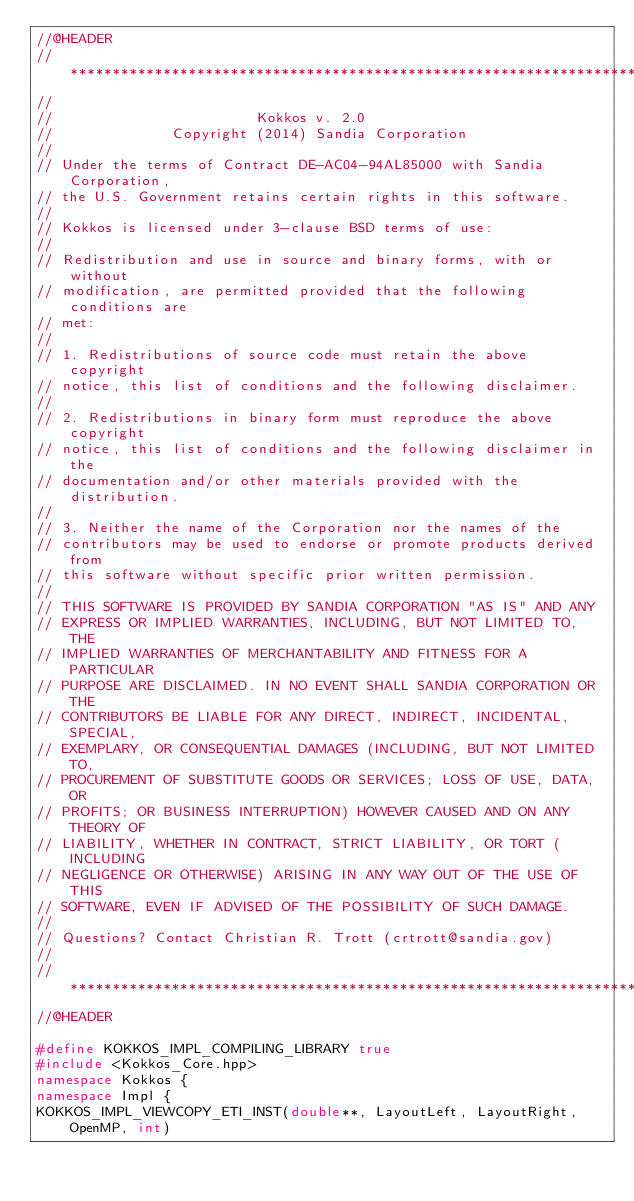Convert code to text. <code><loc_0><loc_0><loc_500><loc_500><_C++_>//@HEADER
// ************************************************************************
//
//                        Kokkos v. 2.0
//              Copyright (2014) Sandia Corporation
//
// Under the terms of Contract DE-AC04-94AL85000 with Sandia Corporation,
// the U.S. Government retains certain rights in this software.
//
// Kokkos is licensed under 3-clause BSD terms of use:
//
// Redistribution and use in source and binary forms, with or without
// modification, are permitted provided that the following conditions are
// met:
//
// 1. Redistributions of source code must retain the above copyright
// notice, this list of conditions and the following disclaimer.
//
// 2. Redistributions in binary form must reproduce the above copyright
// notice, this list of conditions and the following disclaimer in the
// documentation and/or other materials provided with the distribution.
//
// 3. Neither the name of the Corporation nor the names of the
// contributors may be used to endorse or promote products derived from
// this software without specific prior written permission.
//
// THIS SOFTWARE IS PROVIDED BY SANDIA CORPORATION "AS IS" AND ANY
// EXPRESS OR IMPLIED WARRANTIES, INCLUDING, BUT NOT LIMITED TO, THE
// IMPLIED WARRANTIES OF MERCHANTABILITY AND FITNESS FOR A PARTICULAR
// PURPOSE ARE DISCLAIMED. IN NO EVENT SHALL SANDIA CORPORATION OR THE
// CONTRIBUTORS BE LIABLE FOR ANY DIRECT, INDIRECT, INCIDENTAL, SPECIAL,
// EXEMPLARY, OR CONSEQUENTIAL DAMAGES (INCLUDING, BUT NOT LIMITED TO,
// PROCUREMENT OF SUBSTITUTE GOODS OR SERVICES; LOSS OF USE, DATA, OR
// PROFITS; OR BUSINESS INTERRUPTION) HOWEVER CAUSED AND ON ANY THEORY OF
// LIABILITY, WHETHER IN CONTRACT, STRICT LIABILITY, OR TORT (INCLUDING
// NEGLIGENCE OR OTHERWISE) ARISING IN ANY WAY OUT OF THE USE OF THIS
// SOFTWARE, EVEN IF ADVISED OF THE POSSIBILITY OF SUCH DAMAGE.
//
// Questions? Contact Christian R. Trott (crtrott@sandia.gov)
//
// ************************************************************************
//@HEADER

#define KOKKOS_IMPL_COMPILING_LIBRARY true
#include <Kokkos_Core.hpp>
namespace Kokkos {
namespace Impl {
KOKKOS_IMPL_VIEWCOPY_ETI_INST(double**, LayoutLeft, LayoutRight, OpenMP, int)</code> 